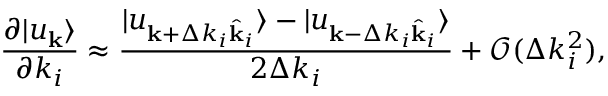<formula> <loc_0><loc_0><loc_500><loc_500>\frac { \partial | u _ { k } \rangle } { \partial k _ { i } } \approx \frac { | u _ { k + \Delta k _ { i } \hat { k } _ { i } } \rangle - | u _ { k - \Delta k _ { i } \hat { k } _ { i } } \rangle } { 2 \Delta k _ { i } } + \mathcal { O } ( \Delta k _ { i } ^ { 2 } ) ,</formula> 